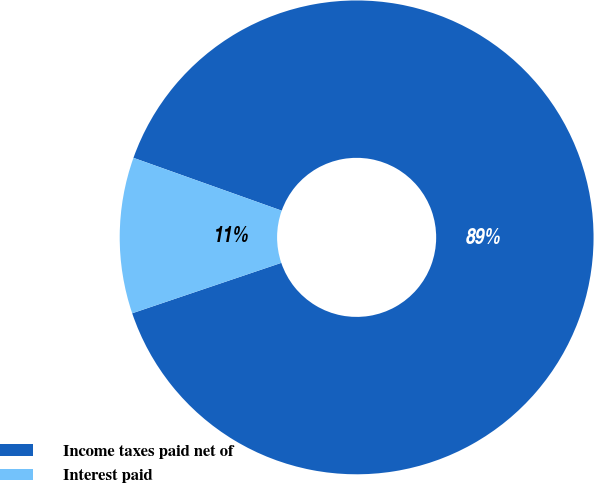<chart> <loc_0><loc_0><loc_500><loc_500><pie_chart><fcel>Income taxes paid net of<fcel>Interest paid<nl><fcel>89.36%<fcel>10.64%<nl></chart> 